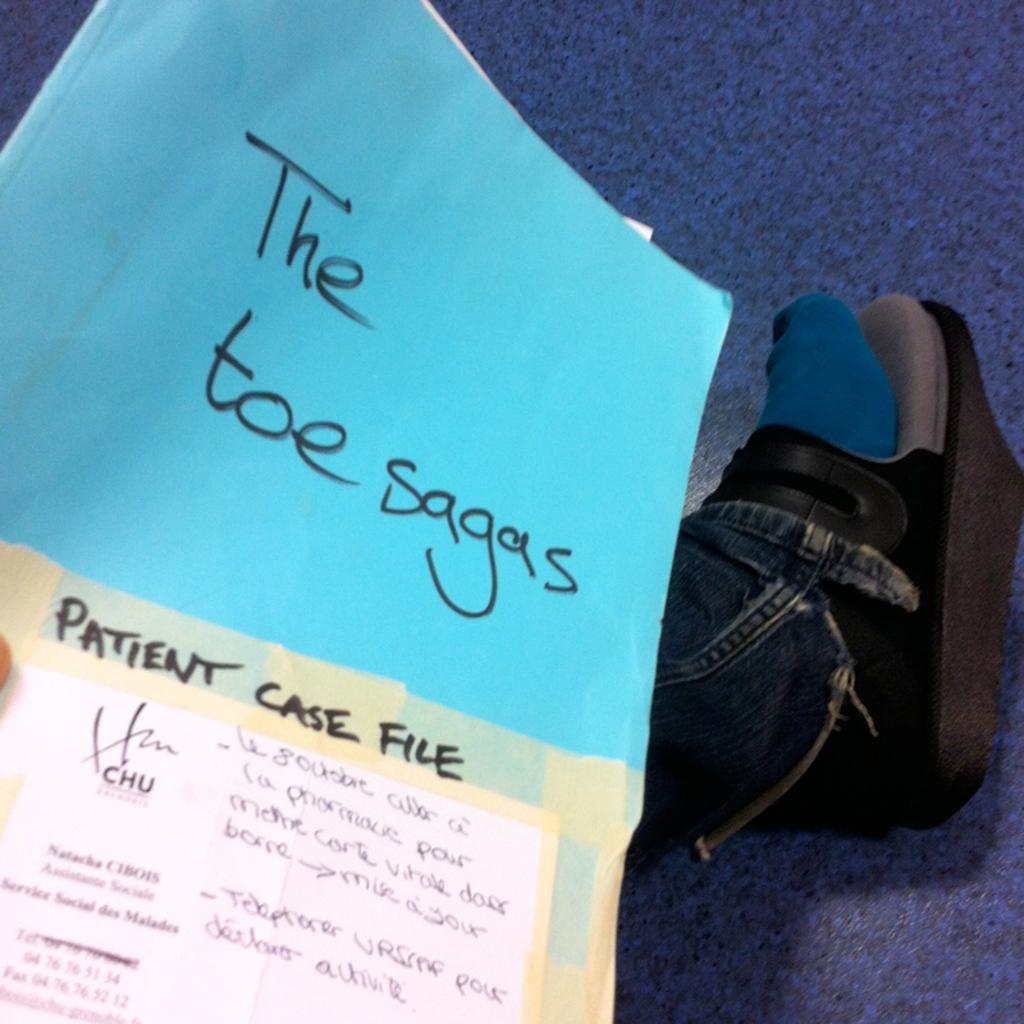What object can be seen in the image related to documents or paperwork? There is a file in the image. What part of a person's body is visible in the image? A person's leg and finger are visible in the image. What color and type of surface is present at the bottom and top of the image? There is a blue color mat at the bottom and top of the image. What type of duck can be seen enjoying the winter season in the image? There is no duck present in the image, nor is there any indication of a winter season. What type of pleasure can be seen being derived from the file in the image? There is no indication of pleasure being derived from the file in the image; it is simply a file. 